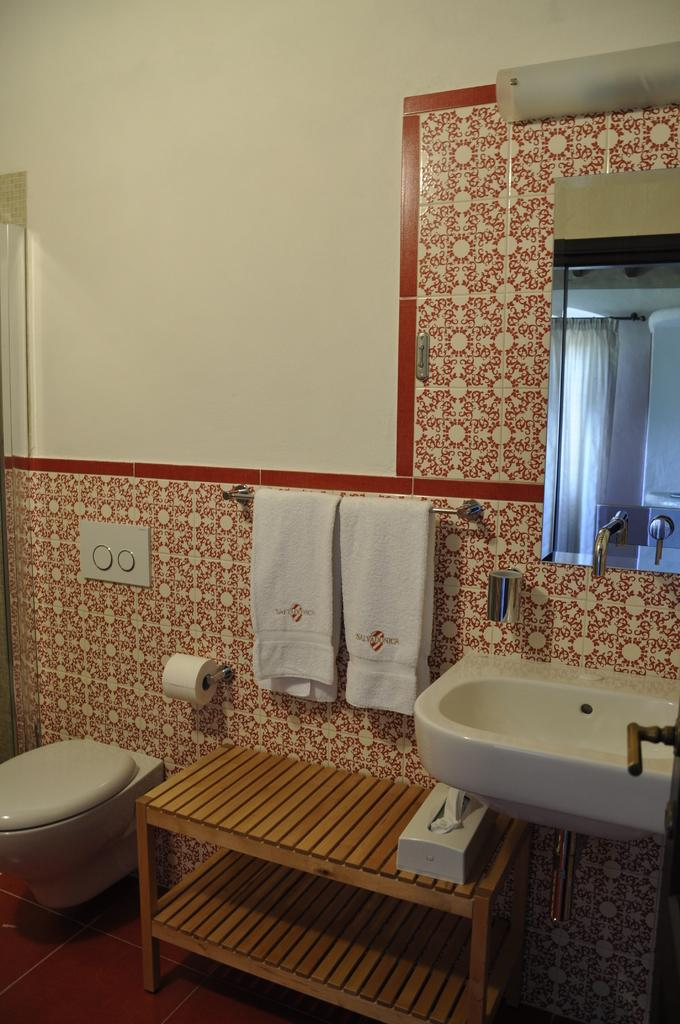What type of fixture is visible in the image? There is a sink in the image. What piece of furniture can be seen in the image? There is a table in the image. What item is available for wiping or blowing one's nose in the image? Tissue paper is present in the image. What can be used for drying hands or other purposes in the image? There are towels to hang in the image. What reflective surface is present in the image? There is a mirror in the image. What type of vertical surface is visible in the image? There is a wall in the image. What type of opening is visible in the image? There is a door in the image. How many oranges are hanging from the door in the image? There are no oranges present in the image. What grade is the mirror in the image? The mirror is not associated with a grade; it is a reflective surface. 